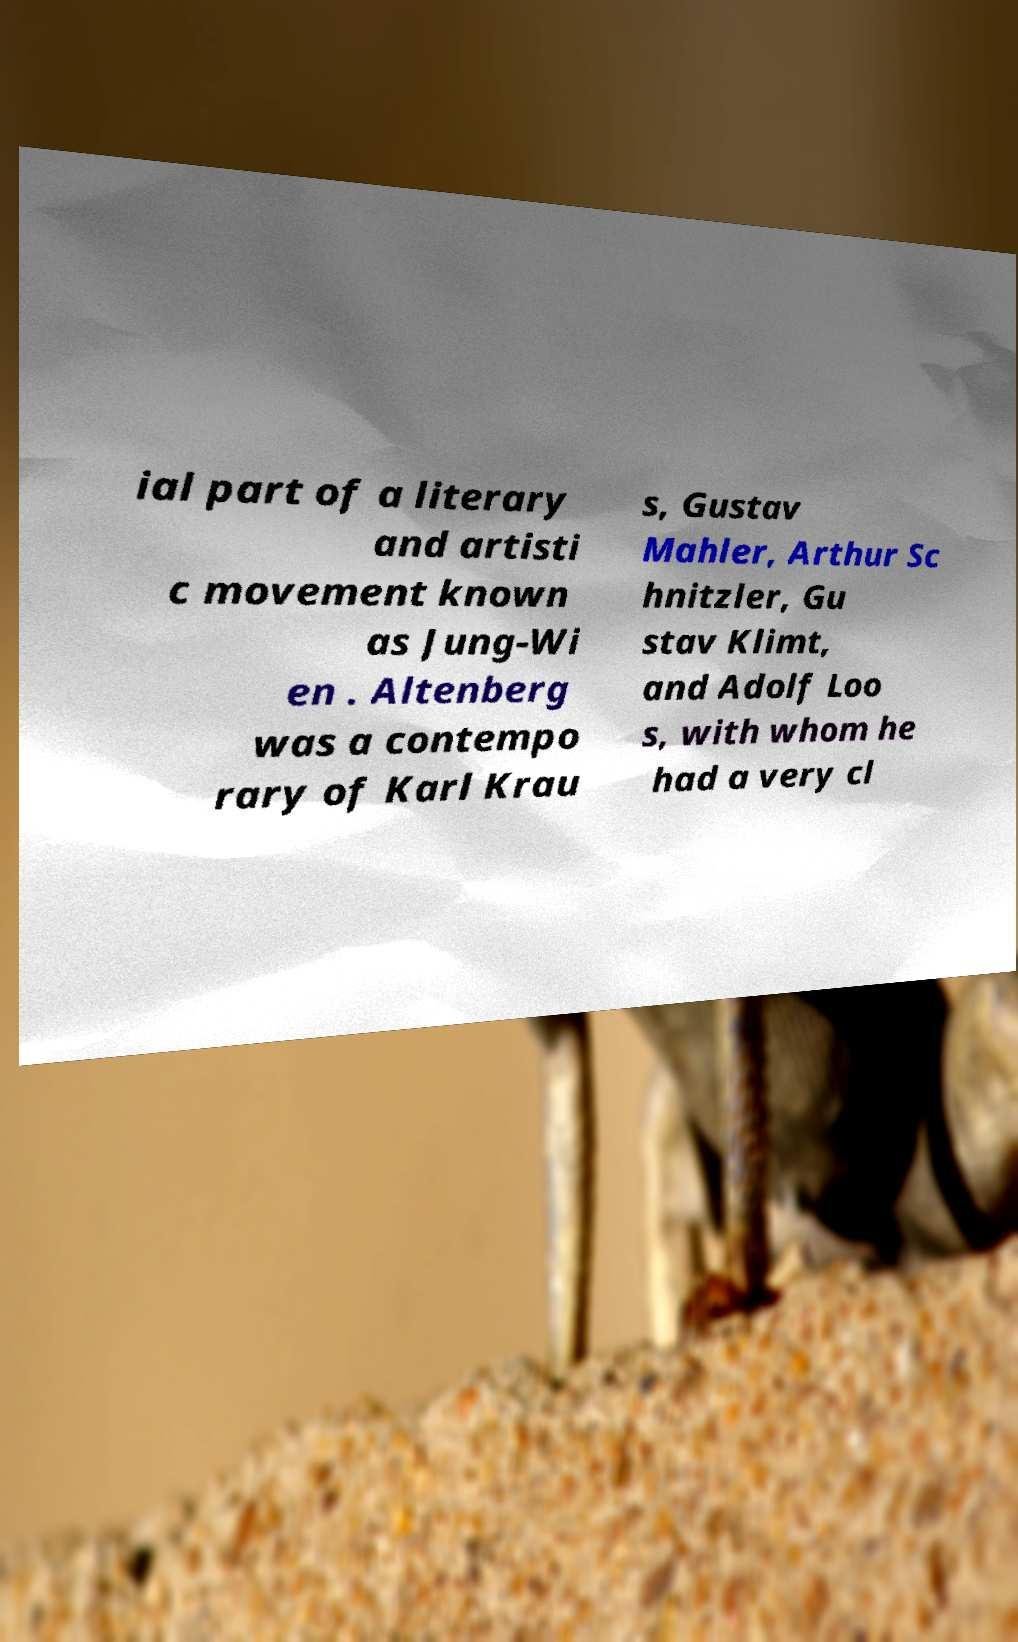Can you accurately transcribe the text from the provided image for me? ial part of a literary and artisti c movement known as Jung-Wi en . Altenberg was a contempo rary of Karl Krau s, Gustav Mahler, Arthur Sc hnitzler, Gu stav Klimt, and Adolf Loo s, with whom he had a very cl 